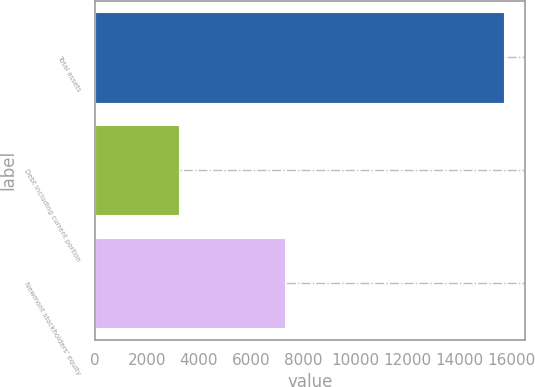<chart> <loc_0><loc_0><loc_500><loc_500><bar_chart><fcel>Total assets<fcel>Debt including current portion<fcel>Newmont stockholders' equity<nl><fcel>15727<fcel>3237<fcel>7291<nl></chart> 